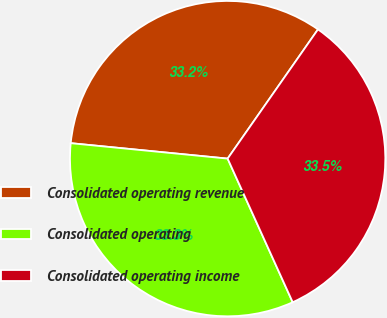<chart> <loc_0><loc_0><loc_500><loc_500><pie_chart><fcel>Consolidated operating revenue<fcel>Consolidated operating<fcel>Consolidated operating income<nl><fcel>33.15%<fcel>33.33%<fcel>33.52%<nl></chart> 